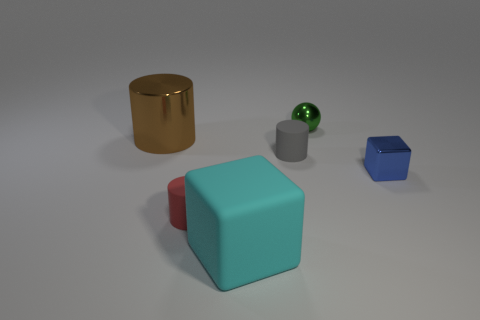If these objects had a symbolic meaning, what might they represent? If we interpret the objects symbolically, the gold cylinder could represent wealth or status, the red sphere might symbolize wholeness or unity, the aqua blue cube may stand for stability and strength, the small gray cylinder could denote functionality or industrialism, and the dark blue rhombic polyhedron might suggest complexity or uniqueness. 